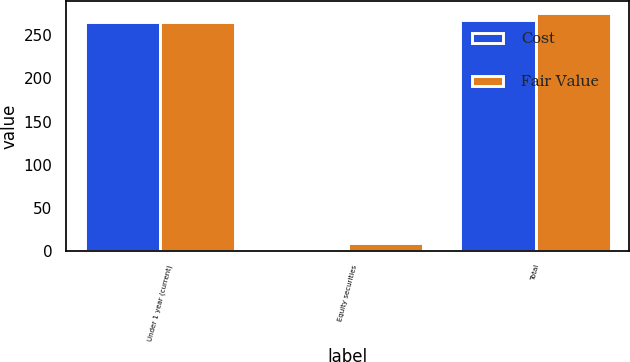Convert chart. <chart><loc_0><loc_0><loc_500><loc_500><stacked_bar_chart><ecel><fcel>Under 1 year (current)<fcel>Equity securities<fcel>Total<nl><fcel>Cost<fcel>265.4<fcel>1.8<fcel>267.2<nl><fcel>Fair Value<fcel>265.5<fcel>9.9<fcel>275.4<nl></chart> 